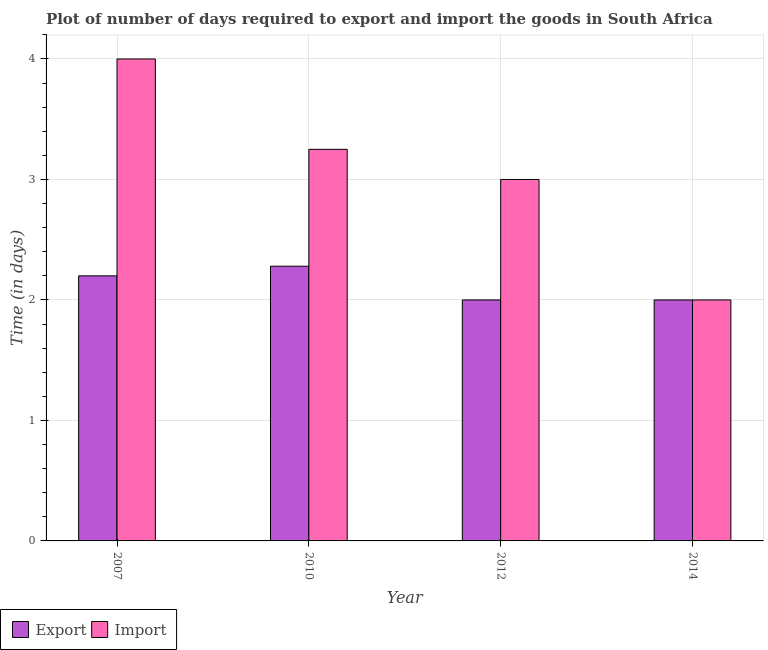How many different coloured bars are there?
Offer a very short reply. 2. How many groups of bars are there?
Provide a succinct answer. 4. Are the number of bars per tick equal to the number of legend labels?
Offer a terse response. Yes. What is the time required to export in 2010?
Ensure brevity in your answer.  2.28. Across all years, what is the maximum time required to import?
Keep it short and to the point. 4. Across all years, what is the minimum time required to export?
Give a very brief answer. 2. In which year was the time required to export maximum?
Offer a terse response. 2010. In which year was the time required to import minimum?
Offer a very short reply. 2014. What is the total time required to export in the graph?
Your answer should be compact. 8.48. What is the difference between the time required to import in 2007 and that in 2010?
Offer a very short reply. 0.75. What is the difference between the time required to import in 2010 and the time required to export in 2007?
Offer a very short reply. -0.75. What is the average time required to export per year?
Ensure brevity in your answer.  2.12. In the year 2014, what is the difference between the time required to export and time required to import?
Offer a terse response. 0. Is the time required to export in 2007 less than that in 2012?
Keep it short and to the point. No. What is the difference between the highest and the lowest time required to export?
Offer a very short reply. 0.28. In how many years, is the time required to export greater than the average time required to export taken over all years?
Ensure brevity in your answer.  2. Is the sum of the time required to import in 2010 and 2012 greater than the maximum time required to export across all years?
Your answer should be compact. Yes. What does the 1st bar from the left in 2012 represents?
Offer a terse response. Export. What does the 2nd bar from the right in 2012 represents?
Offer a very short reply. Export. How many bars are there?
Offer a terse response. 8. Are all the bars in the graph horizontal?
Your response must be concise. No. How many years are there in the graph?
Make the answer very short. 4. What is the difference between two consecutive major ticks on the Y-axis?
Offer a very short reply. 1. Where does the legend appear in the graph?
Offer a very short reply. Bottom left. What is the title of the graph?
Ensure brevity in your answer.  Plot of number of days required to export and import the goods in South Africa. What is the label or title of the Y-axis?
Provide a short and direct response. Time (in days). What is the Time (in days) of Export in 2007?
Give a very brief answer. 2.2. What is the Time (in days) in Import in 2007?
Your answer should be very brief. 4. What is the Time (in days) in Export in 2010?
Your answer should be compact. 2.28. What is the Time (in days) of Export in 2012?
Your answer should be very brief. 2. What is the Time (in days) in Import in 2014?
Make the answer very short. 2. Across all years, what is the maximum Time (in days) in Export?
Provide a short and direct response. 2.28. Across all years, what is the maximum Time (in days) in Import?
Make the answer very short. 4. Across all years, what is the minimum Time (in days) in Export?
Ensure brevity in your answer.  2. What is the total Time (in days) in Export in the graph?
Your response must be concise. 8.48. What is the total Time (in days) in Import in the graph?
Offer a terse response. 12.25. What is the difference between the Time (in days) of Export in 2007 and that in 2010?
Make the answer very short. -0.08. What is the difference between the Time (in days) in Import in 2007 and that in 2014?
Make the answer very short. 2. What is the difference between the Time (in days) in Export in 2010 and that in 2012?
Offer a terse response. 0.28. What is the difference between the Time (in days) of Import in 2010 and that in 2012?
Ensure brevity in your answer.  0.25. What is the difference between the Time (in days) in Export in 2010 and that in 2014?
Your response must be concise. 0.28. What is the difference between the Time (in days) of Import in 2010 and that in 2014?
Make the answer very short. 1.25. What is the difference between the Time (in days) of Export in 2012 and that in 2014?
Provide a short and direct response. 0. What is the difference between the Time (in days) in Export in 2007 and the Time (in days) in Import in 2010?
Keep it short and to the point. -1.05. What is the difference between the Time (in days) of Export in 2007 and the Time (in days) of Import in 2014?
Keep it short and to the point. 0.2. What is the difference between the Time (in days) in Export in 2010 and the Time (in days) in Import in 2012?
Your response must be concise. -0.72. What is the difference between the Time (in days) of Export in 2010 and the Time (in days) of Import in 2014?
Make the answer very short. 0.28. What is the average Time (in days) of Export per year?
Give a very brief answer. 2.12. What is the average Time (in days) in Import per year?
Give a very brief answer. 3.06. In the year 2010, what is the difference between the Time (in days) in Export and Time (in days) in Import?
Your answer should be very brief. -0.97. In the year 2014, what is the difference between the Time (in days) of Export and Time (in days) of Import?
Your answer should be compact. 0. What is the ratio of the Time (in days) in Export in 2007 to that in 2010?
Ensure brevity in your answer.  0.96. What is the ratio of the Time (in days) of Import in 2007 to that in 2010?
Offer a very short reply. 1.23. What is the ratio of the Time (in days) of Export in 2007 to that in 2014?
Keep it short and to the point. 1.1. What is the ratio of the Time (in days) in Export in 2010 to that in 2012?
Provide a succinct answer. 1.14. What is the ratio of the Time (in days) of Export in 2010 to that in 2014?
Offer a terse response. 1.14. What is the ratio of the Time (in days) in Import in 2010 to that in 2014?
Your answer should be very brief. 1.62. What is the ratio of the Time (in days) in Import in 2012 to that in 2014?
Offer a very short reply. 1.5. What is the difference between the highest and the second highest Time (in days) in Export?
Keep it short and to the point. 0.08. What is the difference between the highest and the second highest Time (in days) in Import?
Provide a succinct answer. 0.75. What is the difference between the highest and the lowest Time (in days) of Export?
Ensure brevity in your answer.  0.28. 